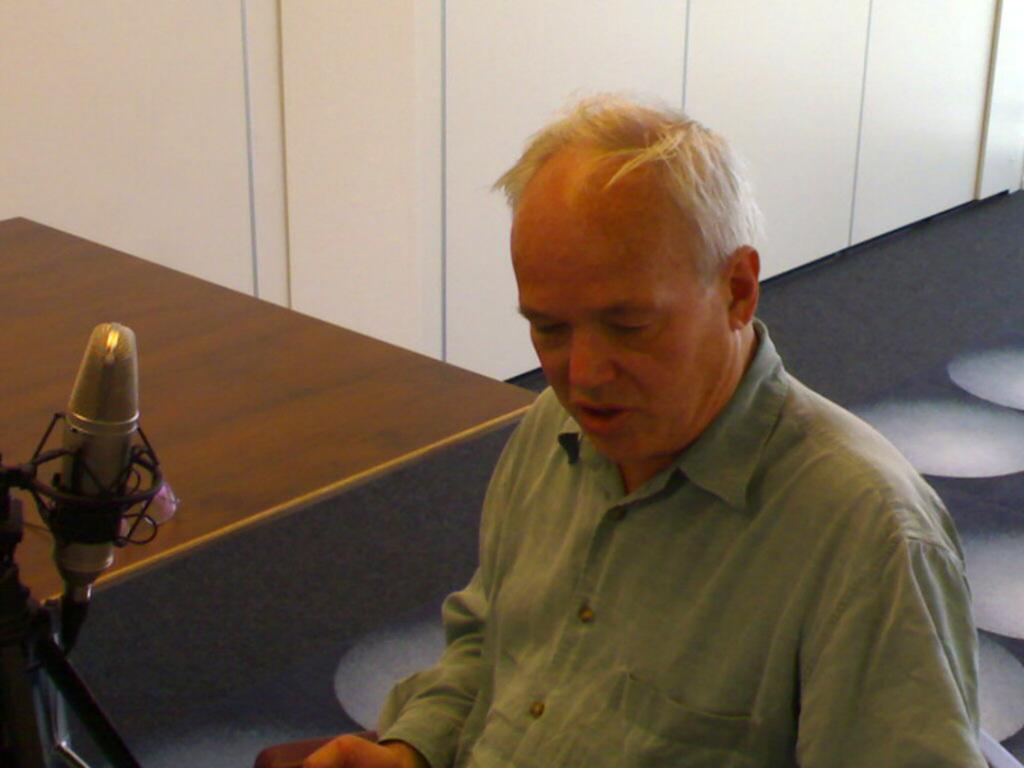Describe this image in one or two sentences. We can see a man. He is wearing green color shirt. We can see wooden table and mic on the left side of the image. There is a wall and black color floor in the background. 